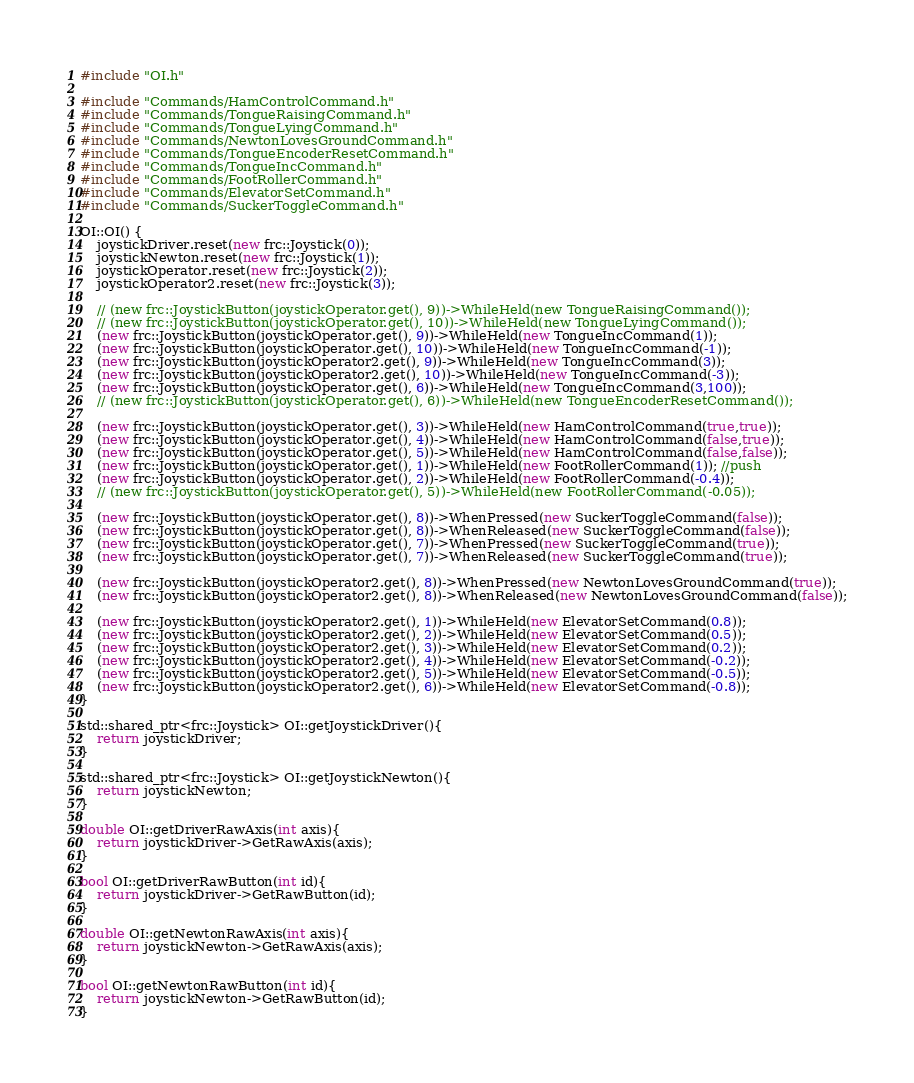<code> <loc_0><loc_0><loc_500><loc_500><_C++_>#include "OI.h"

#include "Commands/HamControlCommand.h"
#include "Commands/TongueRaisingCommand.h"
#include "Commands/TongueLyingCommand.h"
#include "Commands/NewtonLovesGroundCommand.h"
#include "Commands/TongueEncoderResetCommand.h"
#include "Commands/TongueIncCommand.h"
#include "Commands/FootRollerCommand.h"
#include "Commands/ElevatorSetCommand.h"
#include "Commands/SuckerToggleCommand.h"

OI::OI() {
	joystickDriver.reset(new frc::Joystick(0));
	joystickNewton.reset(new frc::Joystick(1));
	joystickOperator.reset(new frc::Joystick(2));
	joystickOperator2.reset(new frc::Joystick(3));

	// (new frc::JoystickButton(joystickOperator.get(), 9))->WhileHeld(new TongueRaisingCommand());
	// (new frc::JoystickButton(joystickOperator.get(), 10))->WhileHeld(new TongueLyingCommand());
	(new frc::JoystickButton(joystickOperator.get(), 9))->WhileHeld(new TongueIncCommand(1));
	(new frc::JoystickButton(joystickOperator.get(), 10))->WhileHeld(new TongueIncCommand(-1));
	(new frc::JoystickButton(joystickOperator2.get(), 9))->WhileHeld(new TongueIncCommand(3));
	(new frc::JoystickButton(joystickOperator2.get(), 10))->WhileHeld(new TongueIncCommand(-3));
	(new frc::JoystickButton(joystickOperator.get(), 6))->WhileHeld(new TongueIncCommand(3,100));
	// (new frc::JoystickButton(joystickOperator.get(), 6))->WhileHeld(new TongueEncoderResetCommand());

	(new frc::JoystickButton(joystickOperator.get(), 3))->WhileHeld(new HamControlCommand(true,true));
	(new frc::JoystickButton(joystickOperator.get(), 4))->WhileHeld(new HamControlCommand(false,true));
	(new frc::JoystickButton(joystickOperator.get(), 5))->WhileHeld(new HamControlCommand(false,false));
	(new frc::JoystickButton(joystickOperator.get(), 1))->WhileHeld(new FootRollerCommand(1)); //push
	(new frc::JoystickButton(joystickOperator.get(), 2))->WhileHeld(new FootRollerCommand(-0.4));
	// (new frc::JoystickButton(joystickOperator.get(), 5))->WhileHeld(new FootRollerCommand(-0.05));

	(new frc::JoystickButton(joystickOperator.get(), 8))->WhenPressed(new SuckerToggleCommand(false));
	(new frc::JoystickButton(joystickOperator.get(), 8))->WhenReleased(new SuckerToggleCommand(false));
	(new frc::JoystickButton(joystickOperator.get(), 7))->WhenPressed(new SuckerToggleCommand(true));
	(new frc::JoystickButton(joystickOperator.get(), 7))->WhenReleased(new SuckerToggleCommand(true));

	(new frc::JoystickButton(joystickOperator2.get(), 8))->WhenPressed(new NewtonLovesGroundCommand(true));
	(new frc::JoystickButton(joystickOperator2.get(), 8))->WhenReleased(new NewtonLovesGroundCommand(false));

	(new frc::JoystickButton(joystickOperator2.get(), 1))->WhileHeld(new ElevatorSetCommand(0.8));
	(new frc::JoystickButton(joystickOperator2.get(), 2))->WhileHeld(new ElevatorSetCommand(0.5));
	(new frc::JoystickButton(joystickOperator2.get(), 3))->WhileHeld(new ElevatorSetCommand(0.2));
	(new frc::JoystickButton(joystickOperator2.get(), 4))->WhileHeld(new ElevatorSetCommand(-0.2));
	(new frc::JoystickButton(joystickOperator2.get(), 5))->WhileHeld(new ElevatorSetCommand(-0.5));
	(new frc::JoystickButton(joystickOperator2.get(), 6))->WhileHeld(new ElevatorSetCommand(-0.8));
}

std::shared_ptr<frc::Joystick> OI::getJoystickDriver(){
	return joystickDriver;
}

std::shared_ptr<frc::Joystick> OI::getJoystickNewton(){
	return joystickNewton;
}

double OI::getDriverRawAxis(int axis){
	return joystickDriver->GetRawAxis(axis);
}

bool OI::getDriverRawButton(int id){
	return joystickDriver->GetRawButton(id);
}

double OI::getNewtonRawAxis(int axis){
	return joystickNewton->GetRawAxis(axis);
}

bool OI::getNewtonRawButton(int id){
	return joystickNewton->GetRawButton(id);
}</code> 